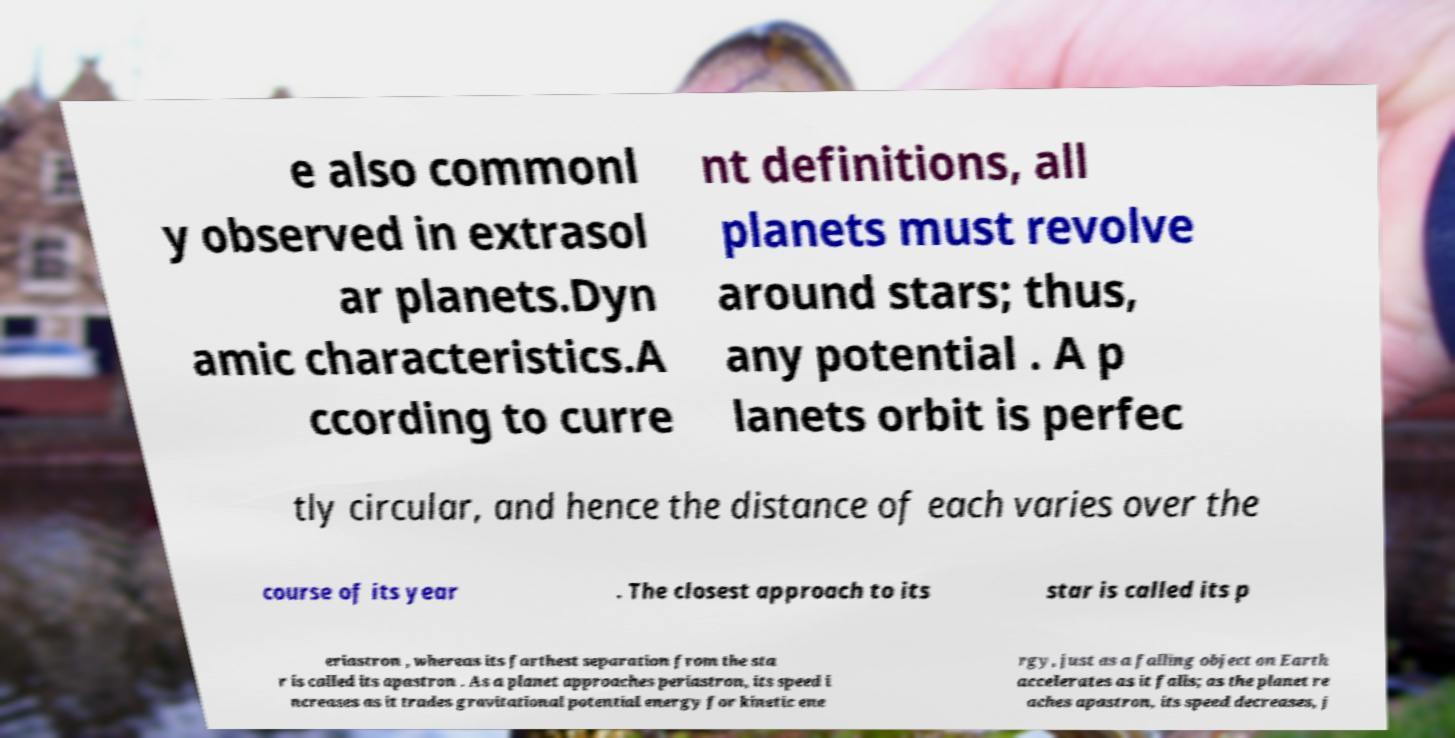Could you assist in decoding the text presented in this image and type it out clearly? e also commonl y observed in extrasol ar planets.Dyn amic characteristics.A ccording to curre nt definitions, all planets must revolve around stars; thus, any potential . A p lanets orbit is perfec tly circular, and hence the distance of each varies over the course of its year . The closest approach to its star is called its p eriastron , whereas its farthest separation from the sta r is called its apastron . As a planet approaches periastron, its speed i ncreases as it trades gravitational potential energy for kinetic ene rgy, just as a falling object on Earth accelerates as it falls; as the planet re aches apastron, its speed decreases, j 